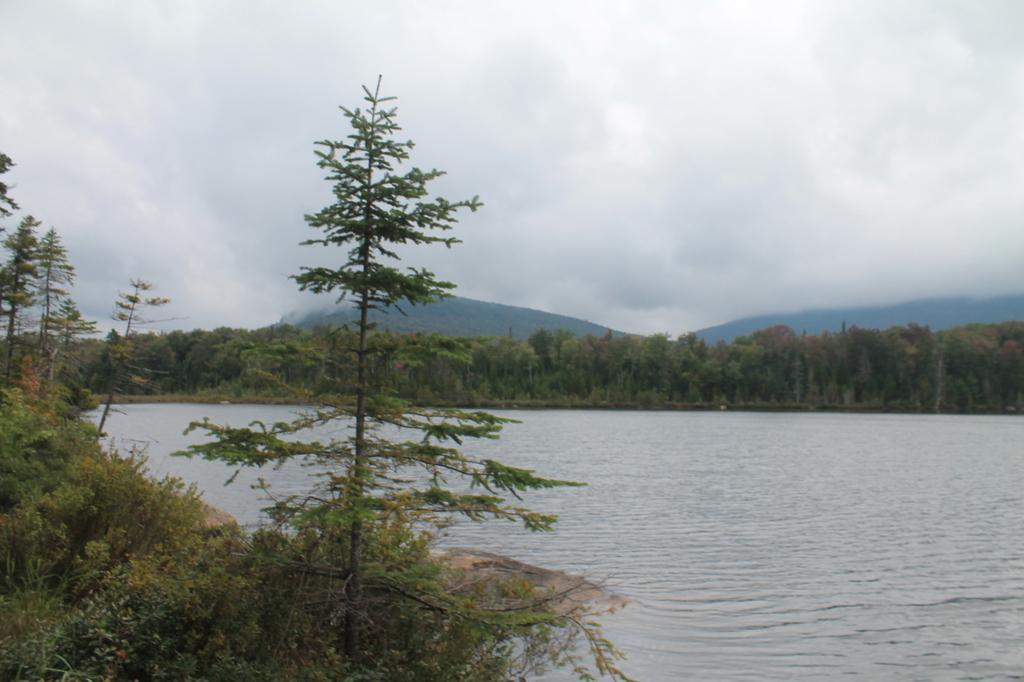Please provide a concise description of this image. This picture is clicked outside. In the foreground we can see the plants and the rocks. In the center we can see a water body. In the background we can see the sky which is full of clouds and we can see the trees and the hills. 